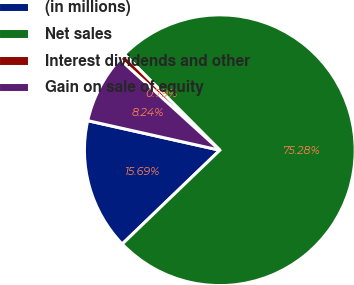<chart> <loc_0><loc_0><loc_500><loc_500><pie_chart><fcel>(in millions)<fcel>Net sales<fcel>Interest dividends and other<fcel>Gain on sale of equity<nl><fcel>15.69%<fcel>75.28%<fcel>0.79%<fcel>8.24%<nl></chart> 